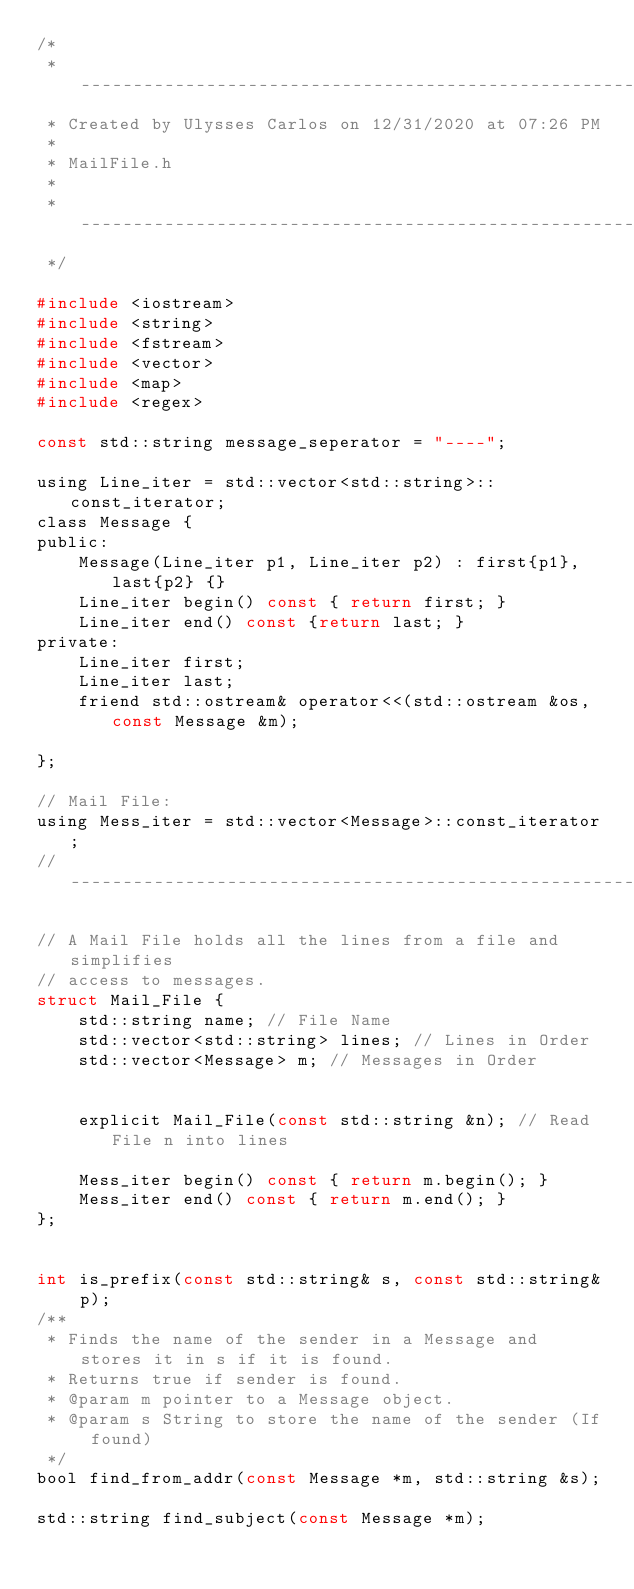Convert code to text. <code><loc_0><loc_0><loc_500><loc_500><_C_>/*
 * -----------------------------------------------------------------------------
 * Created by Ulysses Carlos on 12/31/2020 at 07:26 PM
 * 
 * MailFile.h
 * 
 * -----------------------------------------------------------------------------
 */

#include <iostream>
#include <string>
#include <fstream>
#include <vector>
#include <map>
#include <regex>

const std::string message_seperator = "----";

using Line_iter = std::vector<std::string>::const_iterator;
class Message {
public:
	Message(Line_iter p1, Line_iter p2) : first{p1}, last{p2} {}
	Line_iter begin() const { return first; }
	Line_iter end() const {return last; }
private:
	Line_iter first;
	Line_iter last;
	friend std::ostream& operator<<(std::ostream &os, const Message &m);

};

// Mail File:
using Mess_iter = std::vector<Message>::const_iterator;
//------------------------------------------------------------------------------

// A Mail File holds all the lines from a file and simplifies
// access to messages.
struct Mail_File { 
	std::string name; // File Name
	std::vector<std::string> lines; // Lines in Order
	std::vector<Message> m; // Messages in Order


	explicit Mail_File(const std::string &n); // Read File n into lines

	Mess_iter begin() const { return m.begin(); }
	Mess_iter end() const { return m.end(); }
};


int is_prefix(const std::string& s, const std::string& p);
/**
 * Finds the name of the sender in a Message and stores it in s if it is found.
 * Returns true if sender is found.
 * @param m pointer to a Message object.
 * @param s String to store the name of the sender (If found)
 */
bool find_from_addr(const Message *m, std::string &s);

std::string find_subject(const Message *m);
</code> 